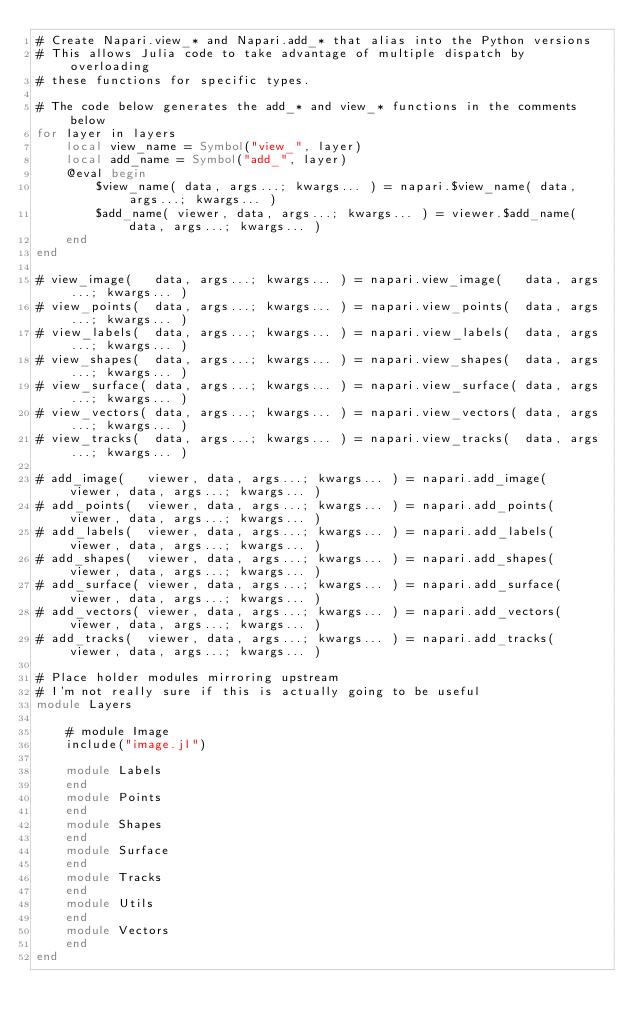Convert code to text. <code><loc_0><loc_0><loc_500><loc_500><_Julia_># Create Napari.view_* and Napari.add_* that alias into the Python versions
# This allows Julia code to take advantage of multiple dispatch by overloading
# these functions for specific types.

# The code below generates the add_* and view_* functions in the comments below
for layer in layers
    local view_name = Symbol("view_", layer)
    local add_name = Symbol("add_", layer)
    @eval begin
        $view_name( data, args...; kwargs... ) = napari.$view_name( data, args...; kwargs... )
        $add_name( viewer, data, args...; kwargs... ) = viewer.$add_name( data, args...; kwargs... )
    end
end

# view_image(   data, args...; kwargs... ) = napari.view_image(   data, args...; kwargs... )
# view_points(  data, args...; kwargs... ) = napari.view_points(  data, args...; kwargs... )
# view_labels(  data, args...; kwargs... ) = napari.view_labels(  data, args...; kwargs... )
# view_shapes(  data, args...; kwargs... ) = napari.view_shapes(  data, args...; kwargs... )
# view_surface( data, args...; kwargs... ) = napari.view_surface( data, args...; kwargs... )
# view_vectors( data, args...; kwargs... ) = napari.view_vectors( data, args...; kwargs... )
# view_tracks(  data, args...; kwargs... ) = napari.view_tracks(  data, args...; kwargs... )

# add_image(   viewer, data, args...; kwargs... ) = napari.add_image(   viewer, data, args...; kwargs... )
# add_points(  viewer, data, args...; kwargs... ) = napari.add_points(  viewer, data, args...; kwargs... )
# add_labels(  viewer, data, args...; kwargs... ) = napari.add_labels(  viewer, data, args...; kwargs... )
# add_shapes(  viewer, data, args...; kwargs... ) = napari.add_shapes(  viewer, data, args...; kwargs... )
# add_surface( viewer, data, args...; kwargs... ) = napari.add_surface( viewer, data, args...; kwargs... )
# add_vectors( viewer, data, args...; kwargs... ) = napari.add_vectors( viewer, data, args...; kwargs... )
# add_tracks(  viewer, data, args...; kwargs... ) = napari.add_tracks(  viewer, data, args...; kwargs... )

# Place holder modules mirroring upstream
# I'm not really sure if this is actually going to be useful
module Layers

    # module Image
    include("image.jl")

    module Labels
    end
    module Points
    end
    module Shapes
    end
    module Surface
    end
    module Tracks
    end
    module Utils
    end
    module Vectors
    end
end

</code> 